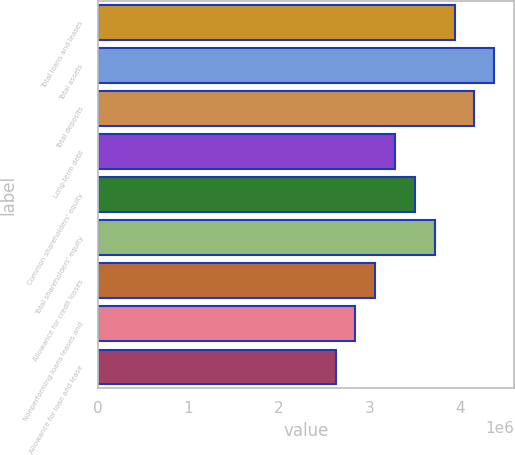Convert chart to OTSL. <chart><loc_0><loc_0><loc_500><loc_500><bar_chart><fcel>Total loans and leases<fcel>Total assets<fcel>Total deposits<fcel>Long-term debt<fcel>Common shareholders' equity<fcel>Total shareholders' equity<fcel>Allowance for credit losses<fcel>Nonperforming loans leases and<fcel>Allowance for loan and lease<nl><fcel>3.93883e+06<fcel>4.37648e+06<fcel>4.15766e+06<fcel>3.28236e+06<fcel>3.50119e+06<fcel>3.72001e+06<fcel>3.06354e+06<fcel>2.84471e+06<fcel>2.62589e+06<nl></chart> 